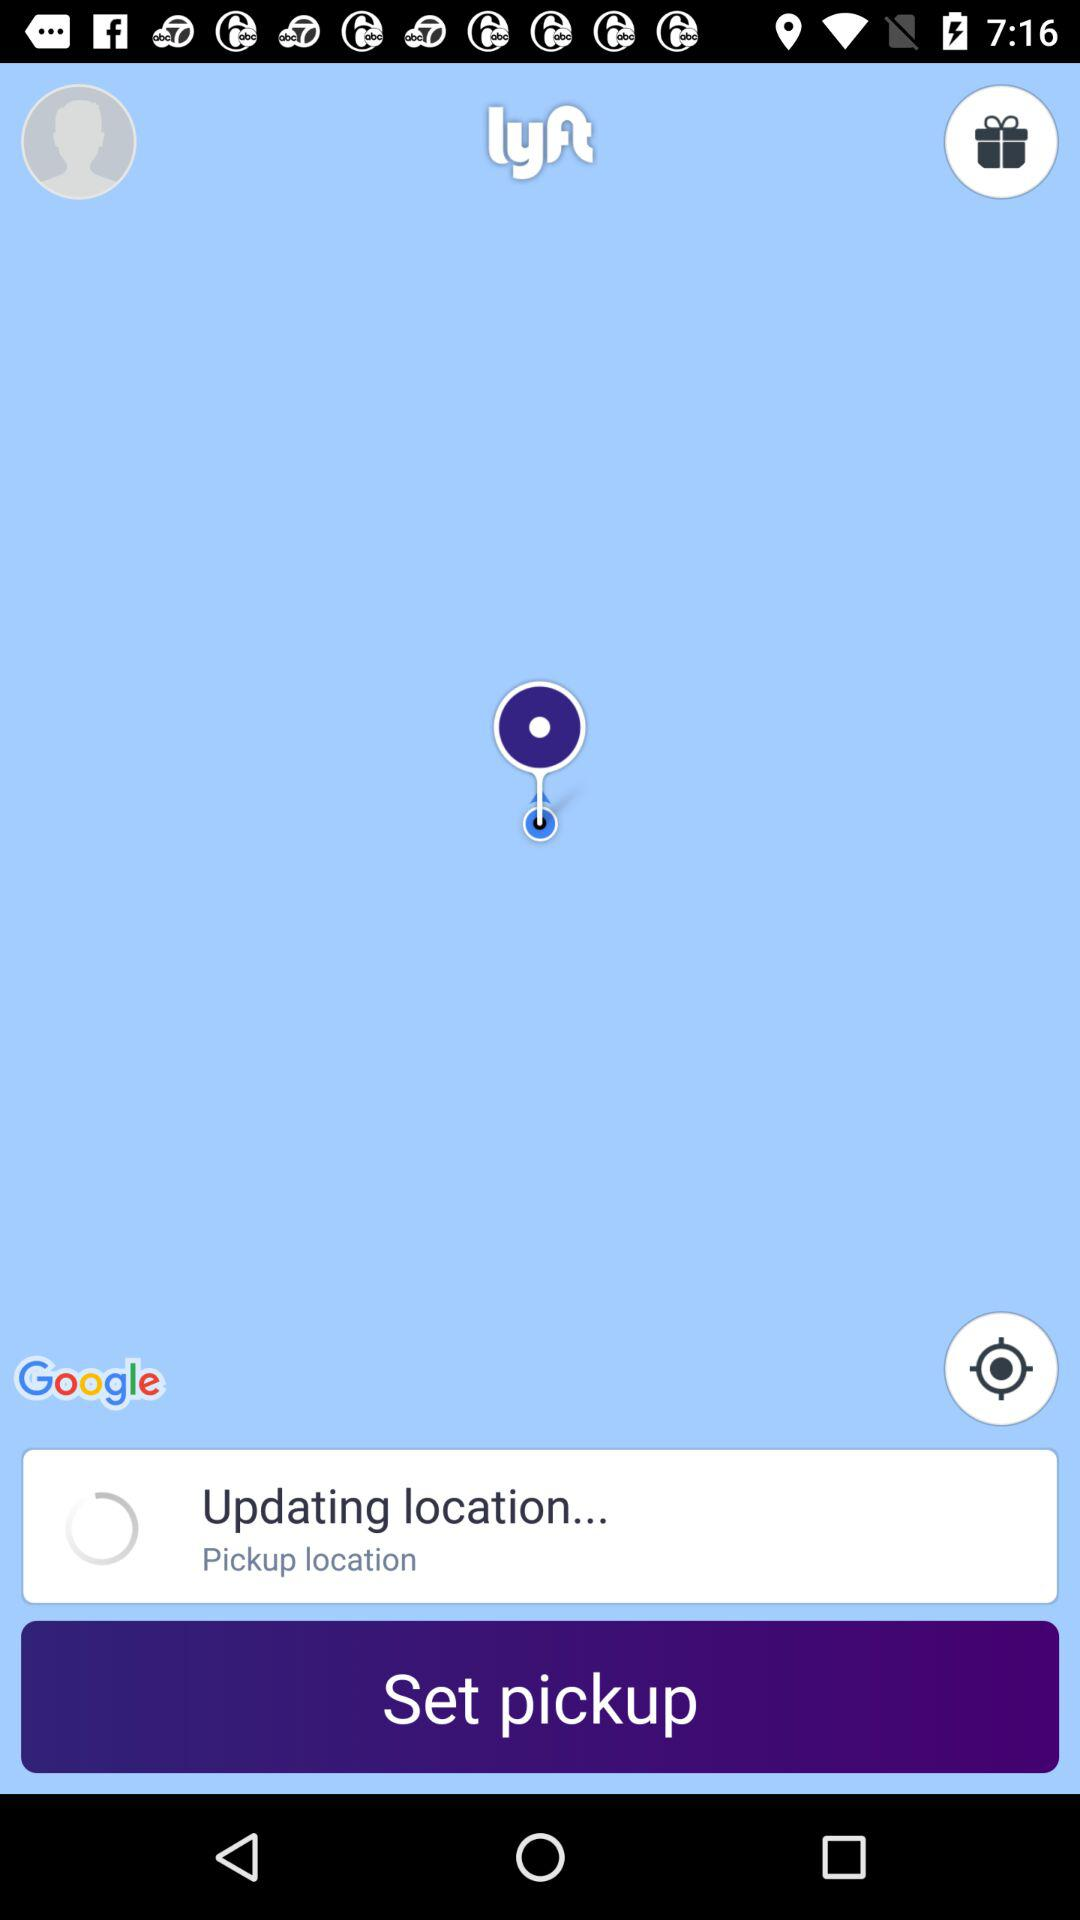What is the name of the application? The name of the application is "lyft". 